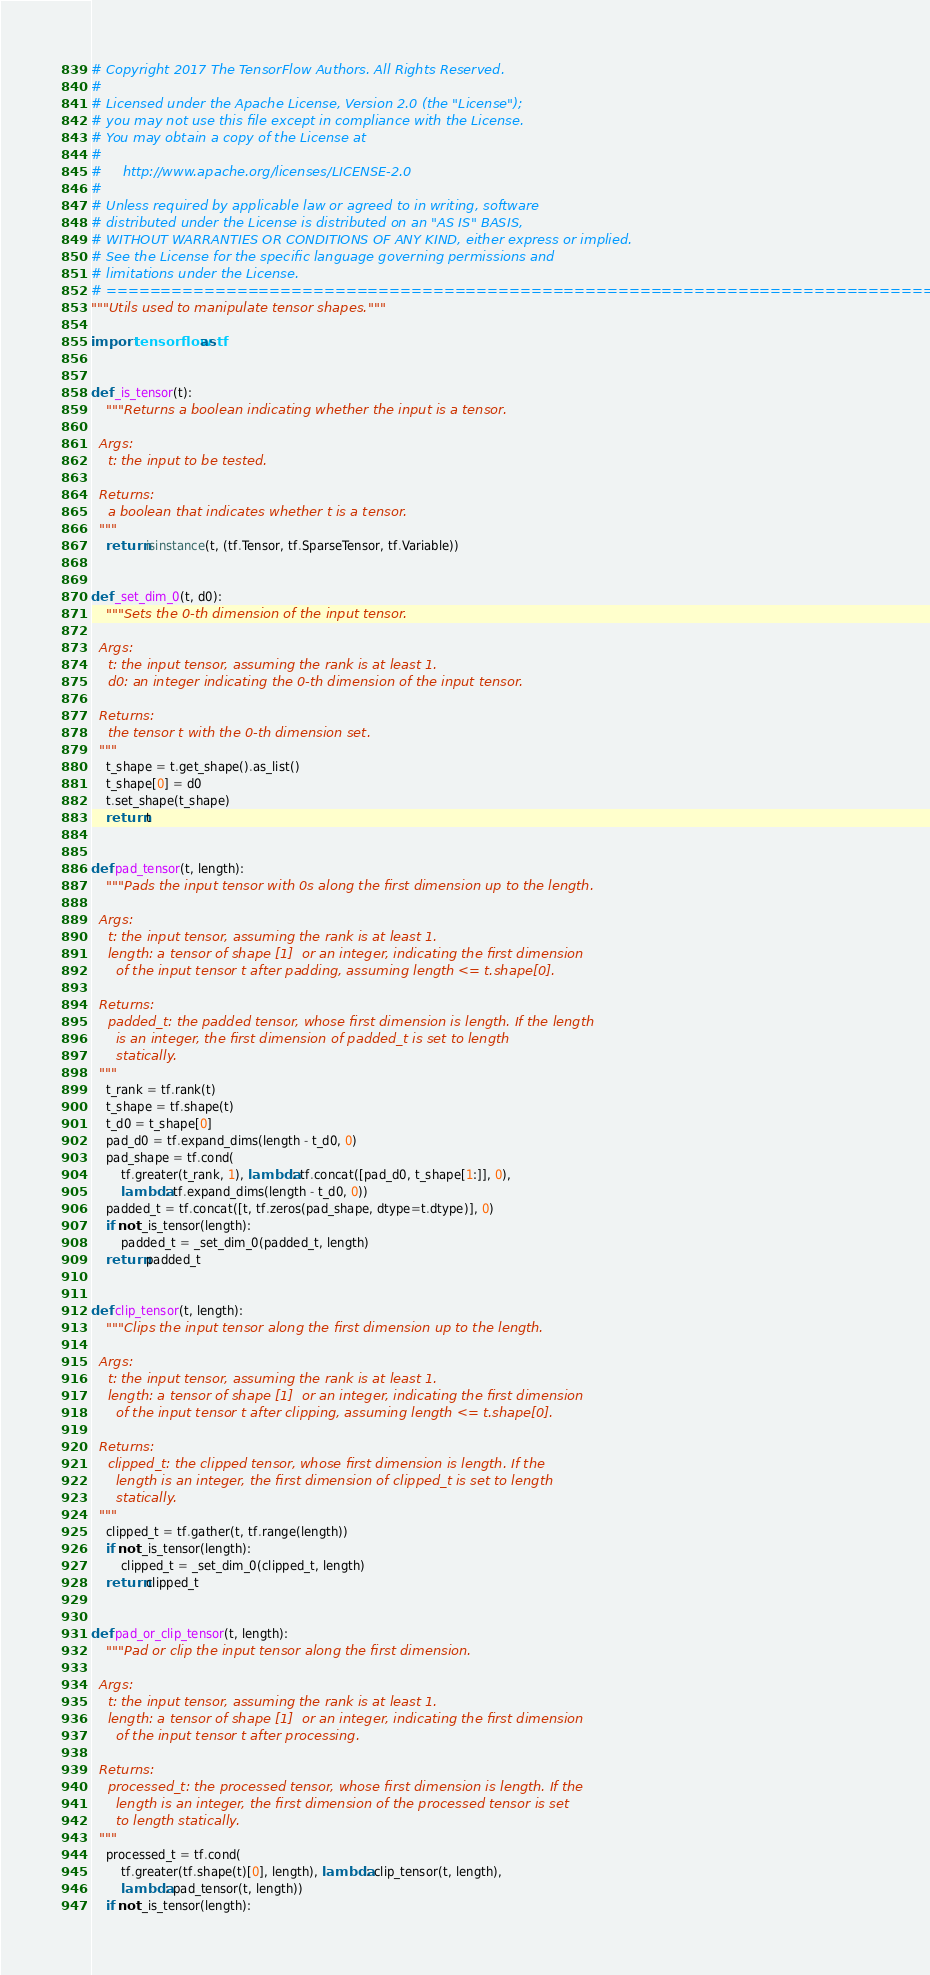<code> <loc_0><loc_0><loc_500><loc_500><_Python_># Copyright 2017 The TensorFlow Authors. All Rights Reserved.
#
# Licensed under the Apache License, Version 2.0 (the "License");
# you may not use this file except in compliance with the License.
# You may obtain a copy of the License at
#
#     http://www.apache.org/licenses/LICENSE-2.0
#
# Unless required by applicable law or agreed to in writing, software
# distributed under the License is distributed on an "AS IS" BASIS,
# WITHOUT WARRANTIES OR CONDITIONS OF ANY KIND, either express or implied.
# See the License for the specific language governing permissions and
# limitations under the License.
# ==============================================================================
"""Utils used to manipulate tensor shapes."""

import tensorflow as tf


def _is_tensor(t):
    """Returns a boolean indicating whether the input is a tensor.

  Args:
    t: the input to be tested.

  Returns:
    a boolean that indicates whether t is a tensor.
  """
    return isinstance(t, (tf.Tensor, tf.SparseTensor, tf.Variable))


def _set_dim_0(t, d0):
    """Sets the 0-th dimension of the input tensor.

  Args:
    t: the input tensor, assuming the rank is at least 1.
    d0: an integer indicating the 0-th dimension of the input tensor.

  Returns:
    the tensor t with the 0-th dimension set.
  """
    t_shape = t.get_shape().as_list()
    t_shape[0] = d0
    t.set_shape(t_shape)
    return t


def pad_tensor(t, length):
    """Pads the input tensor with 0s along the first dimension up to the length.

  Args:
    t: the input tensor, assuming the rank is at least 1.
    length: a tensor of shape [1]  or an integer, indicating the first dimension
      of the input tensor t after padding, assuming length <= t.shape[0].

  Returns:
    padded_t: the padded tensor, whose first dimension is length. If the length
      is an integer, the first dimension of padded_t is set to length
      statically.
  """
    t_rank = tf.rank(t)
    t_shape = tf.shape(t)
    t_d0 = t_shape[0]
    pad_d0 = tf.expand_dims(length - t_d0, 0)
    pad_shape = tf.cond(
        tf.greater(t_rank, 1), lambda: tf.concat([pad_d0, t_shape[1:]], 0),
        lambda: tf.expand_dims(length - t_d0, 0))
    padded_t = tf.concat([t, tf.zeros(pad_shape, dtype=t.dtype)], 0)
    if not _is_tensor(length):
        padded_t = _set_dim_0(padded_t, length)
    return padded_t


def clip_tensor(t, length):
    """Clips the input tensor along the first dimension up to the length.

  Args:
    t: the input tensor, assuming the rank is at least 1.
    length: a tensor of shape [1]  or an integer, indicating the first dimension
      of the input tensor t after clipping, assuming length <= t.shape[0].

  Returns:
    clipped_t: the clipped tensor, whose first dimension is length. If the
      length is an integer, the first dimension of clipped_t is set to length
      statically.
  """
    clipped_t = tf.gather(t, tf.range(length))
    if not _is_tensor(length):
        clipped_t = _set_dim_0(clipped_t, length)
    return clipped_t


def pad_or_clip_tensor(t, length):
    """Pad or clip the input tensor along the first dimension.

  Args:
    t: the input tensor, assuming the rank is at least 1.
    length: a tensor of shape [1]  or an integer, indicating the first dimension
      of the input tensor t after processing.

  Returns:
    processed_t: the processed tensor, whose first dimension is length. If the
      length is an integer, the first dimension of the processed tensor is set
      to length statically.
  """
    processed_t = tf.cond(
        tf.greater(tf.shape(t)[0], length), lambda: clip_tensor(t, length),
        lambda: pad_tensor(t, length))
    if not _is_tensor(length):</code> 